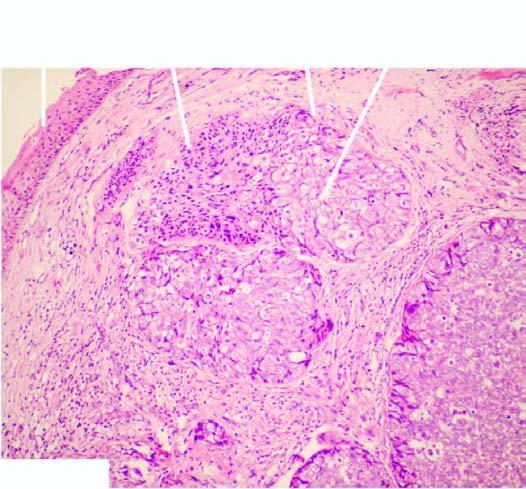do islands of invading malignant squamous cells have sebaceous differentiation appreciated by foamy, vacuolated cytoplasm?
Answer the question using a single word or phrase. No 